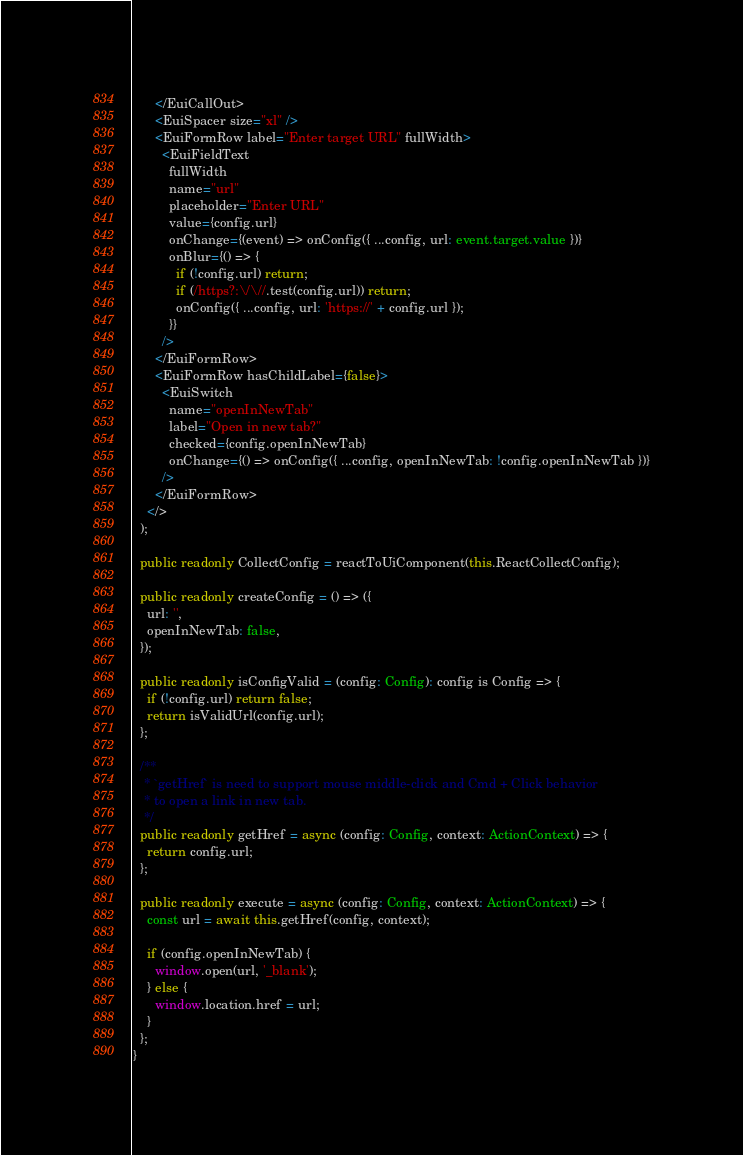<code> <loc_0><loc_0><loc_500><loc_500><_TypeScript_>      </EuiCallOut>
      <EuiSpacer size="xl" />
      <EuiFormRow label="Enter target URL" fullWidth>
        <EuiFieldText
          fullWidth
          name="url"
          placeholder="Enter URL"
          value={config.url}
          onChange={(event) => onConfig({ ...config, url: event.target.value })}
          onBlur={() => {
            if (!config.url) return;
            if (/https?:\/\//.test(config.url)) return;
            onConfig({ ...config, url: 'https://' + config.url });
          }}
        />
      </EuiFormRow>
      <EuiFormRow hasChildLabel={false}>
        <EuiSwitch
          name="openInNewTab"
          label="Open in new tab?"
          checked={config.openInNewTab}
          onChange={() => onConfig({ ...config, openInNewTab: !config.openInNewTab })}
        />
      </EuiFormRow>
    </>
  );

  public readonly CollectConfig = reactToUiComponent(this.ReactCollectConfig);

  public readonly createConfig = () => ({
    url: '',
    openInNewTab: false,
  });

  public readonly isConfigValid = (config: Config): config is Config => {
    if (!config.url) return false;
    return isValidUrl(config.url);
  };

  /**
   * `getHref` is need to support mouse middle-click and Cmd + Click behavior
   * to open a link in new tab.
   */
  public readonly getHref = async (config: Config, context: ActionContext) => {
    return config.url;
  };

  public readonly execute = async (config: Config, context: ActionContext) => {
    const url = await this.getHref(config, context);

    if (config.openInNewTab) {
      window.open(url, '_blank');
    } else {
      window.location.href = url;
    }
  };
}
</code> 